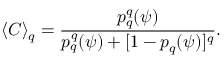<formula> <loc_0><loc_0><loc_500><loc_500>\langle C \rangle _ { q } = \frac { p _ { q } ^ { q } ( \psi ) } { p _ { q } ^ { q } ( \psi ) + [ 1 - p _ { q } ( \psi ) ] ^ { q } } .</formula> 